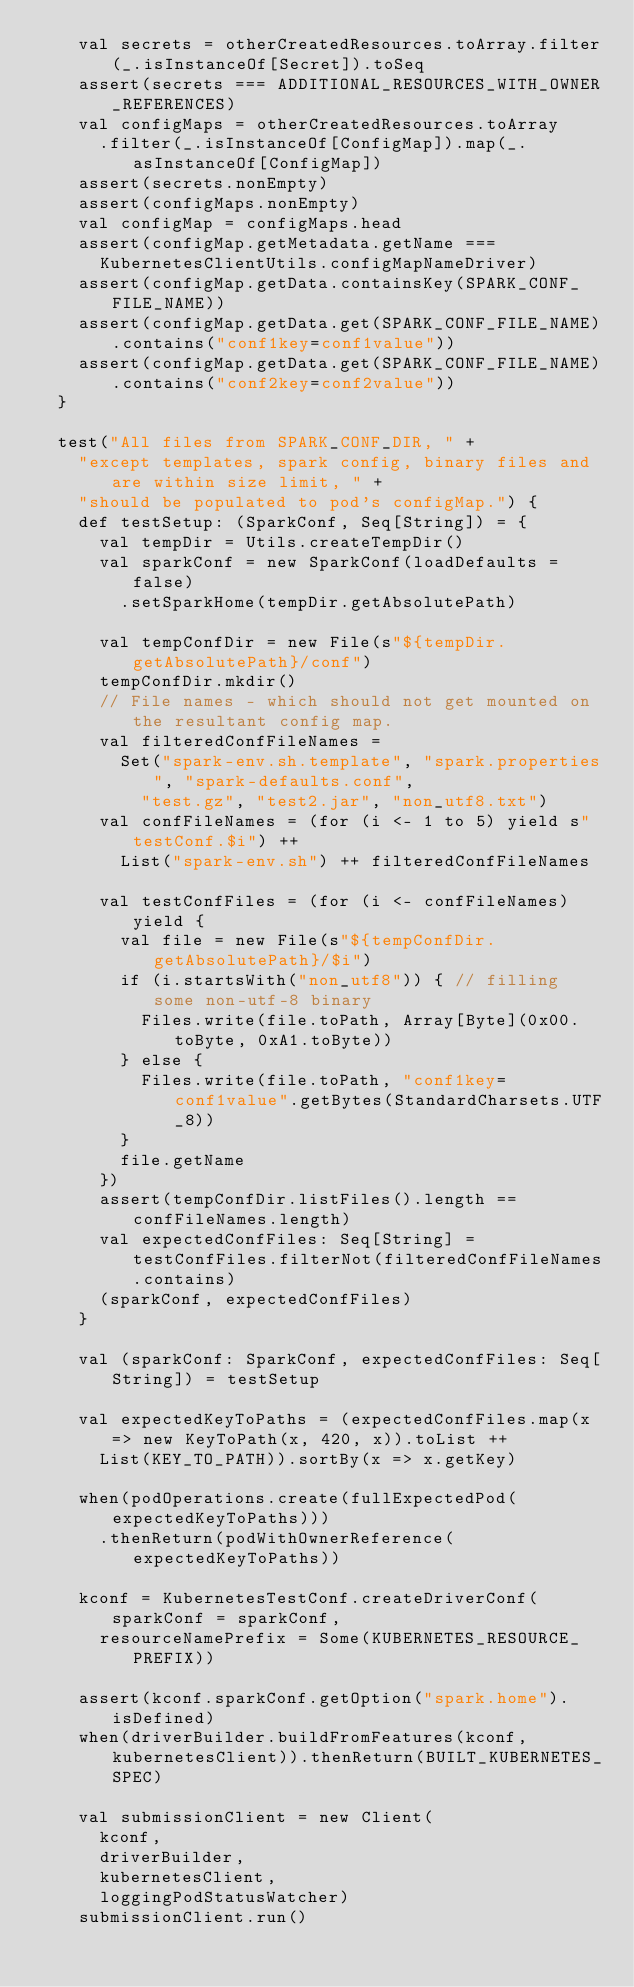Convert code to text. <code><loc_0><loc_0><loc_500><loc_500><_Scala_>    val secrets = otherCreatedResources.toArray.filter(_.isInstanceOf[Secret]).toSeq
    assert(secrets === ADDITIONAL_RESOURCES_WITH_OWNER_REFERENCES)
    val configMaps = otherCreatedResources.toArray
      .filter(_.isInstanceOf[ConfigMap]).map(_.asInstanceOf[ConfigMap])
    assert(secrets.nonEmpty)
    assert(configMaps.nonEmpty)
    val configMap = configMaps.head
    assert(configMap.getMetadata.getName ===
      KubernetesClientUtils.configMapNameDriver)
    assert(configMap.getData.containsKey(SPARK_CONF_FILE_NAME))
    assert(configMap.getData.get(SPARK_CONF_FILE_NAME).contains("conf1key=conf1value"))
    assert(configMap.getData.get(SPARK_CONF_FILE_NAME).contains("conf2key=conf2value"))
  }

  test("All files from SPARK_CONF_DIR, " +
    "except templates, spark config, binary files and are within size limit, " +
    "should be populated to pod's configMap.") {
    def testSetup: (SparkConf, Seq[String]) = {
      val tempDir = Utils.createTempDir()
      val sparkConf = new SparkConf(loadDefaults = false)
        .setSparkHome(tempDir.getAbsolutePath)

      val tempConfDir = new File(s"${tempDir.getAbsolutePath}/conf")
      tempConfDir.mkdir()
      // File names - which should not get mounted on the resultant config map.
      val filteredConfFileNames =
        Set("spark-env.sh.template", "spark.properties", "spark-defaults.conf",
          "test.gz", "test2.jar", "non_utf8.txt")
      val confFileNames = (for (i <- 1 to 5) yield s"testConf.$i") ++
        List("spark-env.sh") ++ filteredConfFileNames

      val testConfFiles = (for (i <- confFileNames) yield {
        val file = new File(s"${tempConfDir.getAbsolutePath}/$i")
        if (i.startsWith("non_utf8")) { // filling some non-utf-8 binary
          Files.write(file.toPath, Array[Byte](0x00.toByte, 0xA1.toByte))
        } else {
          Files.write(file.toPath, "conf1key=conf1value".getBytes(StandardCharsets.UTF_8))
        }
        file.getName
      })
      assert(tempConfDir.listFiles().length == confFileNames.length)
      val expectedConfFiles: Seq[String] = testConfFiles.filterNot(filteredConfFileNames.contains)
      (sparkConf, expectedConfFiles)
    }

    val (sparkConf: SparkConf, expectedConfFiles: Seq[String]) = testSetup

    val expectedKeyToPaths = (expectedConfFiles.map(x => new KeyToPath(x, 420, x)).toList ++
      List(KEY_TO_PATH)).sortBy(x => x.getKey)

    when(podOperations.create(fullExpectedPod(expectedKeyToPaths)))
      .thenReturn(podWithOwnerReference(expectedKeyToPaths))

    kconf = KubernetesTestConf.createDriverConf(sparkConf = sparkConf,
      resourceNamePrefix = Some(KUBERNETES_RESOURCE_PREFIX))

    assert(kconf.sparkConf.getOption("spark.home").isDefined)
    when(driverBuilder.buildFromFeatures(kconf, kubernetesClient)).thenReturn(BUILT_KUBERNETES_SPEC)

    val submissionClient = new Client(
      kconf,
      driverBuilder,
      kubernetesClient,
      loggingPodStatusWatcher)
    submissionClient.run()</code> 